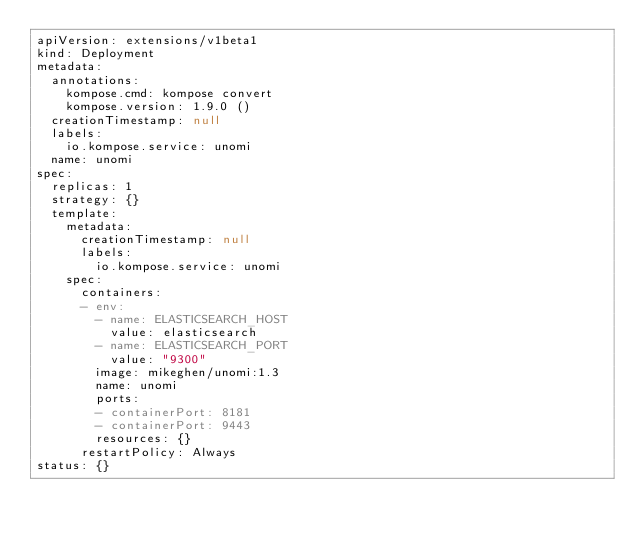Convert code to text. <code><loc_0><loc_0><loc_500><loc_500><_YAML_>apiVersion: extensions/v1beta1
kind: Deployment
metadata:
  annotations:
    kompose.cmd: kompose convert
    kompose.version: 1.9.0 ()
  creationTimestamp: null
  labels:
    io.kompose.service: unomi
  name: unomi
spec:
  replicas: 1
  strategy: {}
  template:
    metadata:
      creationTimestamp: null
      labels:
        io.kompose.service: unomi
    spec:
      containers:
      - env:
        - name: ELASTICSEARCH_HOST
          value: elasticsearch
        - name: ELASTICSEARCH_PORT
          value: "9300"
        image: mikeghen/unomi:1.3
        name: unomi
        ports:
        - containerPort: 8181
        - containerPort: 9443
        resources: {}
      restartPolicy: Always
status: {}
</code> 